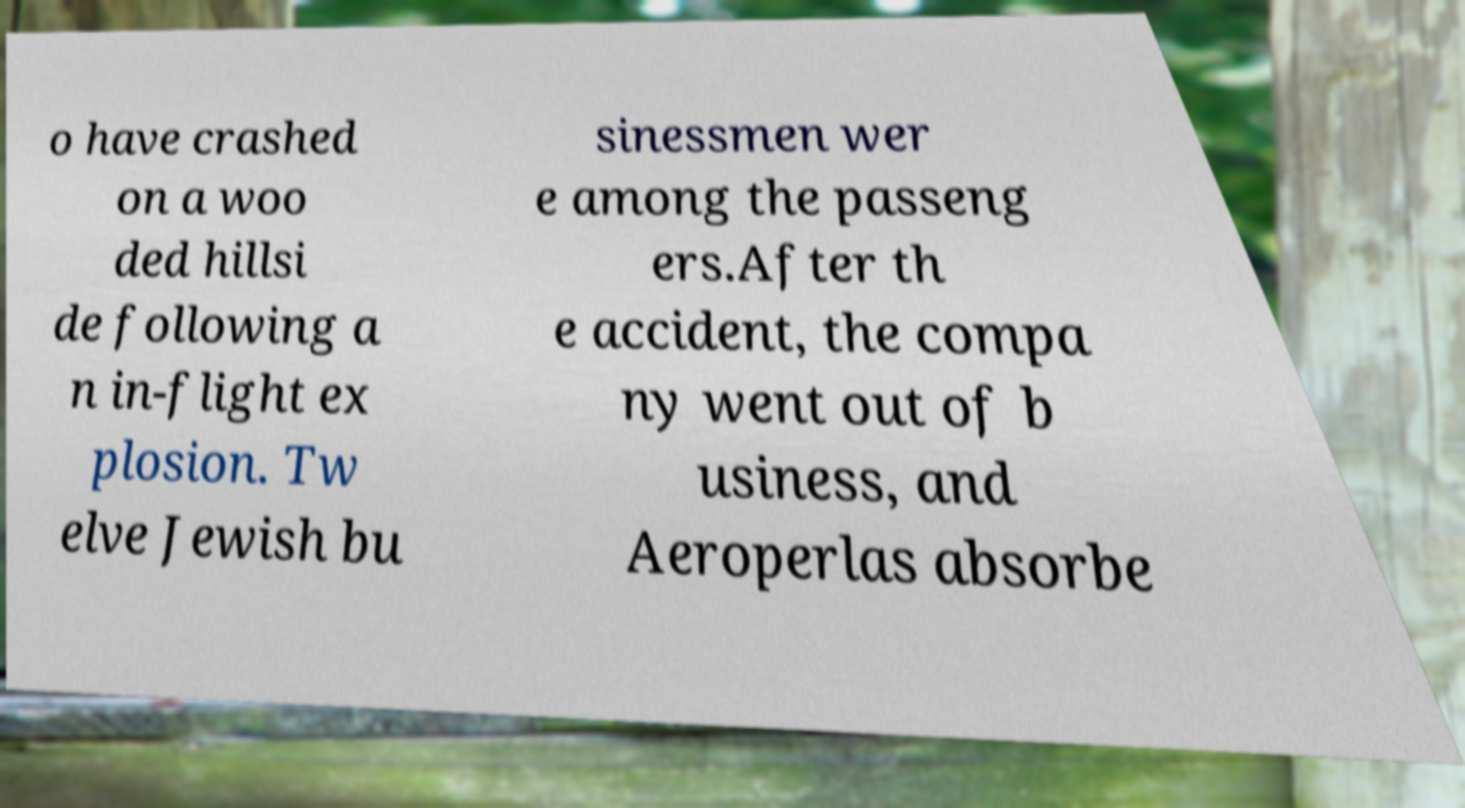Can you accurately transcribe the text from the provided image for me? o have crashed on a woo ded hillsi de following a n in-flight ex plosion. Tw elve Jewish bu sinessmen wer e among the passeng ers.After th e accident, the compa ny went out of b usiness, and Aeroperlas absorbe 